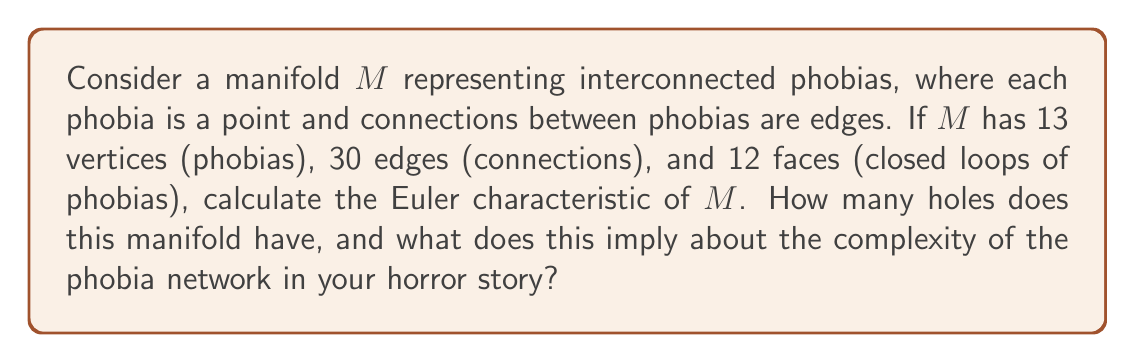Solve this math problem. 1. The Euler characteristic $\chi$ of a manifold is given by the formula:
   $$\chi = V - E + F$$
   where $V$ is the number of vertices, $E$ is the number of edges, and $F$ is the number of faces.

2. Given:
   $V = 13$ (phobias)
   $E = 30$ (connections)
   $F = 12$ (closed loops)

3. Calculate the Euler characteristic:
   $$\chi = 13 - 30 + 12 = -5$$

4. For a closed orientable surface, the Euler characteristic is related to the genus $g$ (number of holes) by the formula:
   $$\chi = 2 - 2g$$

5. Solve for $g$:
   $$-5 = 2 - 2g$$
   $$-7 = -2g$$
   $$g = \frac{7}{2} = 3.5$$

6. Since the genus must be a whole number, we round up to $g = 4$.

7. Interpretation: The manifold has 4 holes, implying a complex network of interconnected phobias. This suggests a rich, multi-layered fear structure for the horror story, where phobias are deeply intertwined and can lead to unexpected consequences or manifestations of fear.
Answer: $\chi = -5$, $g = 4$ 